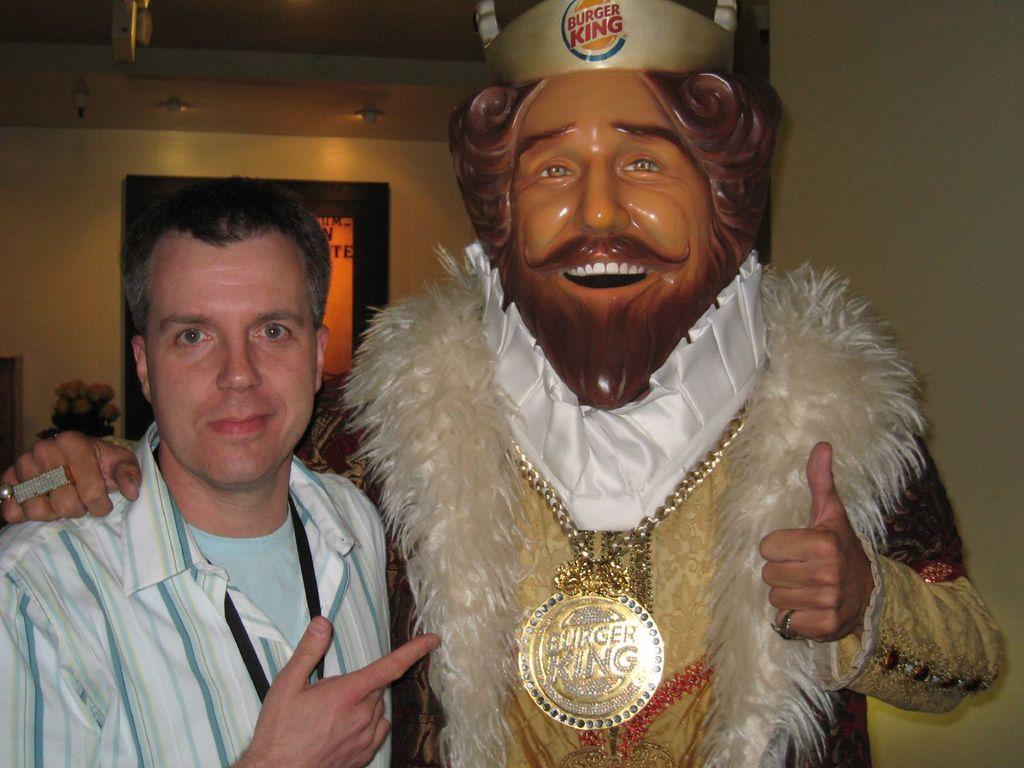How many people are in the image? There are two persons standing in the image. What is one person wearing on their face? One person is wearing a mask on their face. What can be seen in the background of the image? There is a wall and a door in the background of the image. What role does the actor play in the aftermath of the event depicted in the image? There is no actor or event depicted in the image; it simply shows two people standing with one wearing a mask. 